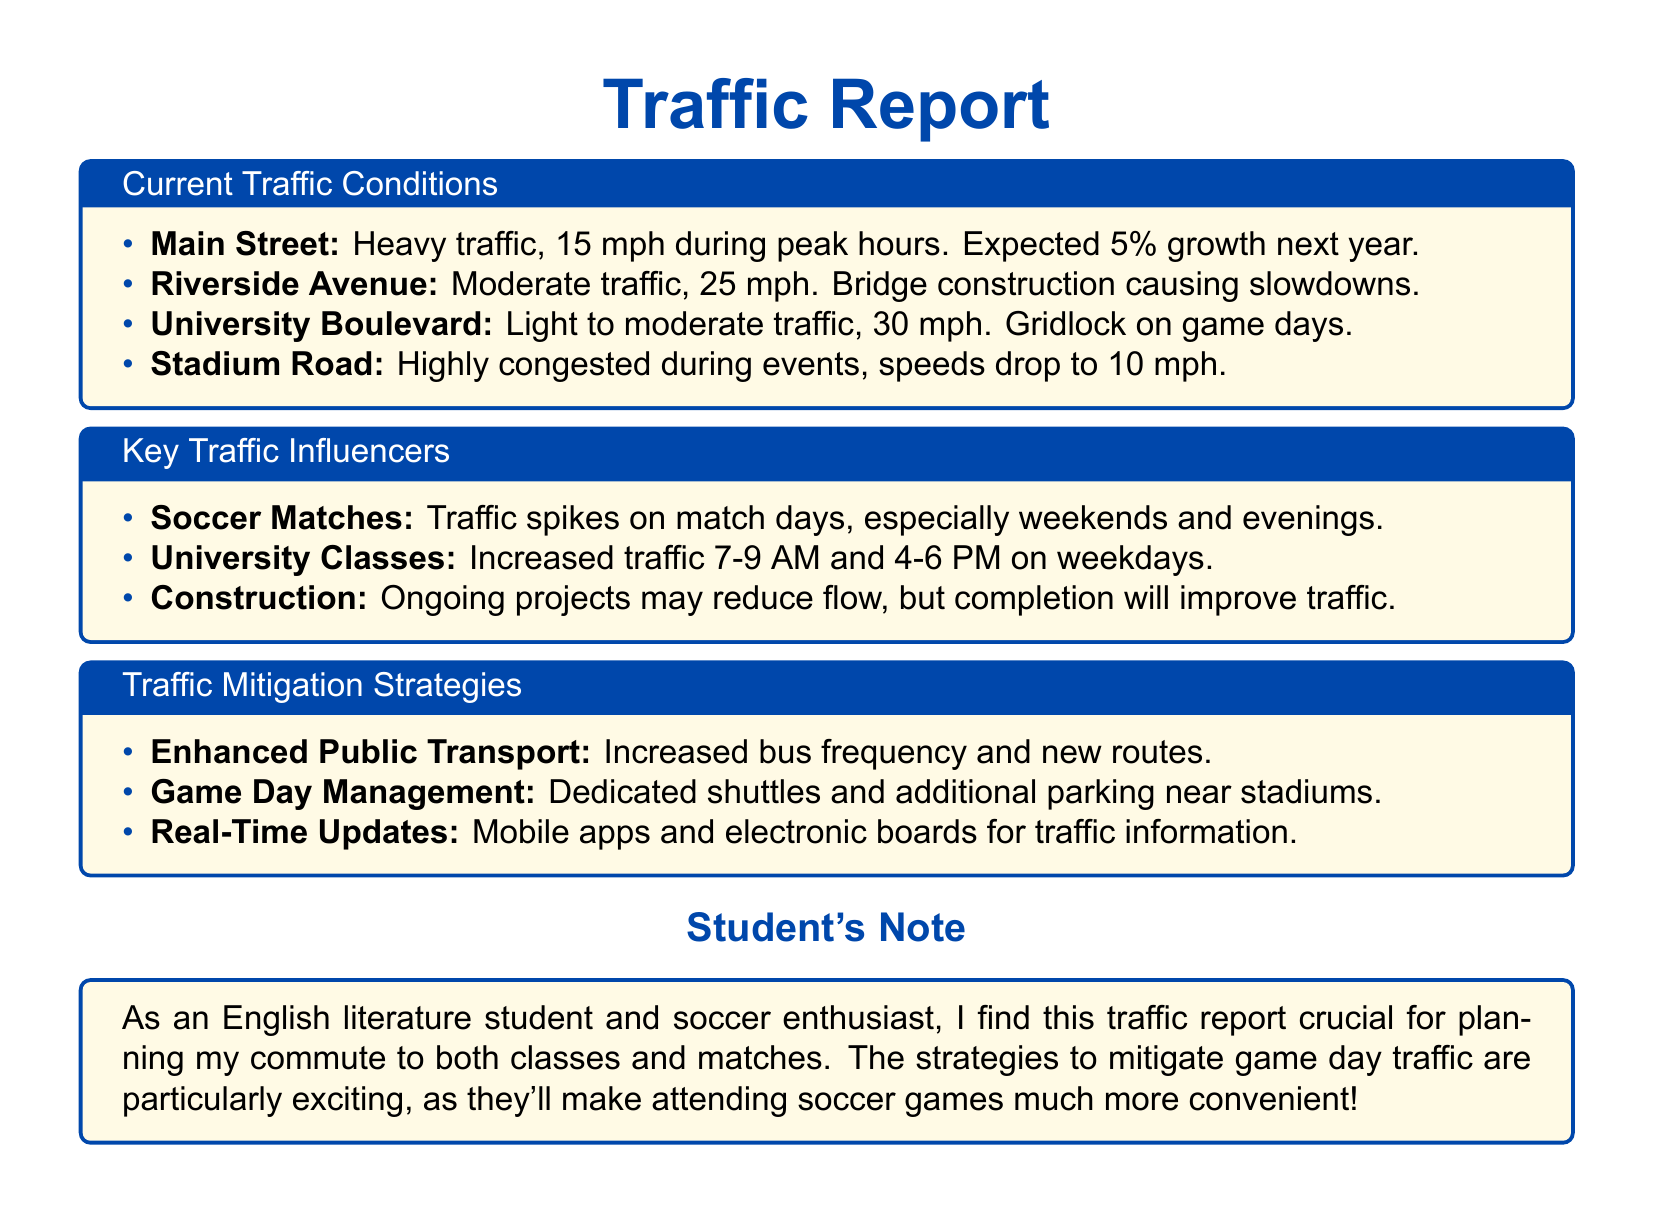What is the speed limit on Main Street during peak hours? The speed limit on Main Street during peak hours is reported as 15 mph due to heavy traffic conditions.
Answer: 15 mph What factor is causing slowdowns on Riverside Avenue? The document indicates that bridge construction is the factor causing slowdowns on Riverside Avenue.
Answer: Bridge construction What is the predicted traffic growth percentage for Main Street next year? The report states that Main Street is expected to see a 5% growth in traffic next year.
Answer: 5% When does traffic peak due to University classes? The document indicates traffic peaks from 7-9 AM and 4-6 PM on weekdays due to University classes.
Answer: 7-9 AM and 4-6 PM What is the speed on Stadium Road during events? The report specifies that speeds on Stadium Road drop to 10 mph during events due to high congestion.
Answer: 10 mph What traffic management strategy involves shuttles? The document mentions "Game Day Management" as a strategy that includes dedicated shuttles.
Answer: Game Day Management What time are soccer matches likely to cause traffic spikes? According to the document, soccer matches cause traffic spikes primarily on weekends and evenings.
Answer: Weekends and evenings What is one way to receive real-time traffic updates? The report states that mobile apps and electronic boards are used to provide traffic information in real-time.
Answer: Mobile apps and electronic boards 